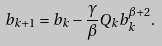<formula> <loc_0><loc_0><loc_500><loc_500>b _ { k + 1 } = b _ { k } - \frac { \gamma } { \beta } Q _ { k } b _ { k } ^ { \beta + 2 } .</formula> 